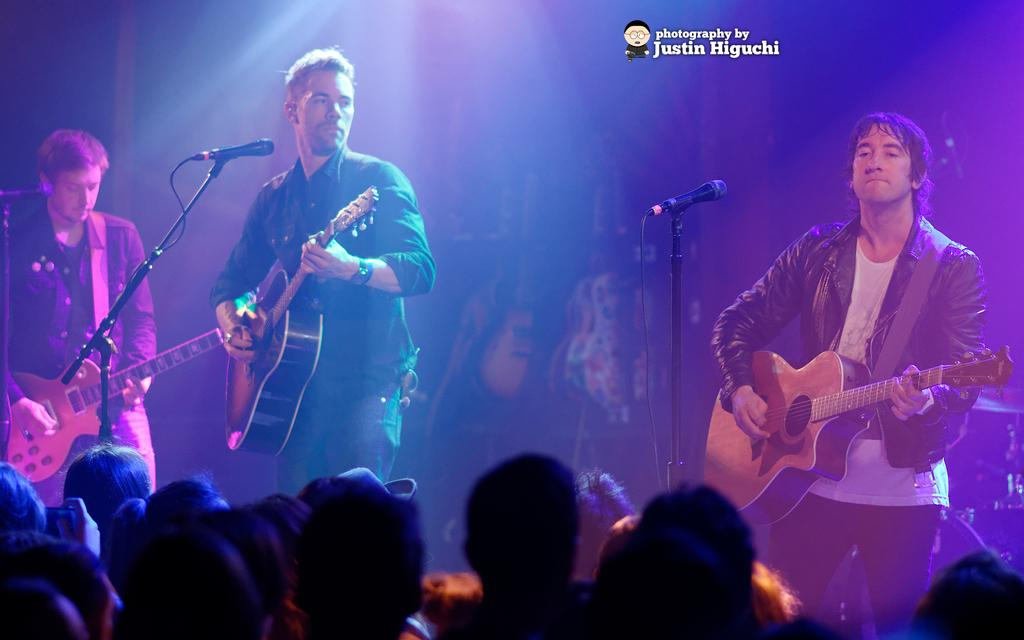What is the main subject of the image? The main subject of the image is a group of people. Can you describe the specific activity of the three persons on the stage? The three persons on the stage are playing musical instruments. What can be seen in the background of the image? There are lights visible in the background of the image. What type of beef is being served to the audience in the image? There is no beef or food being served in the image; the focus is on the group of people and the three persons playing musical instruments. 